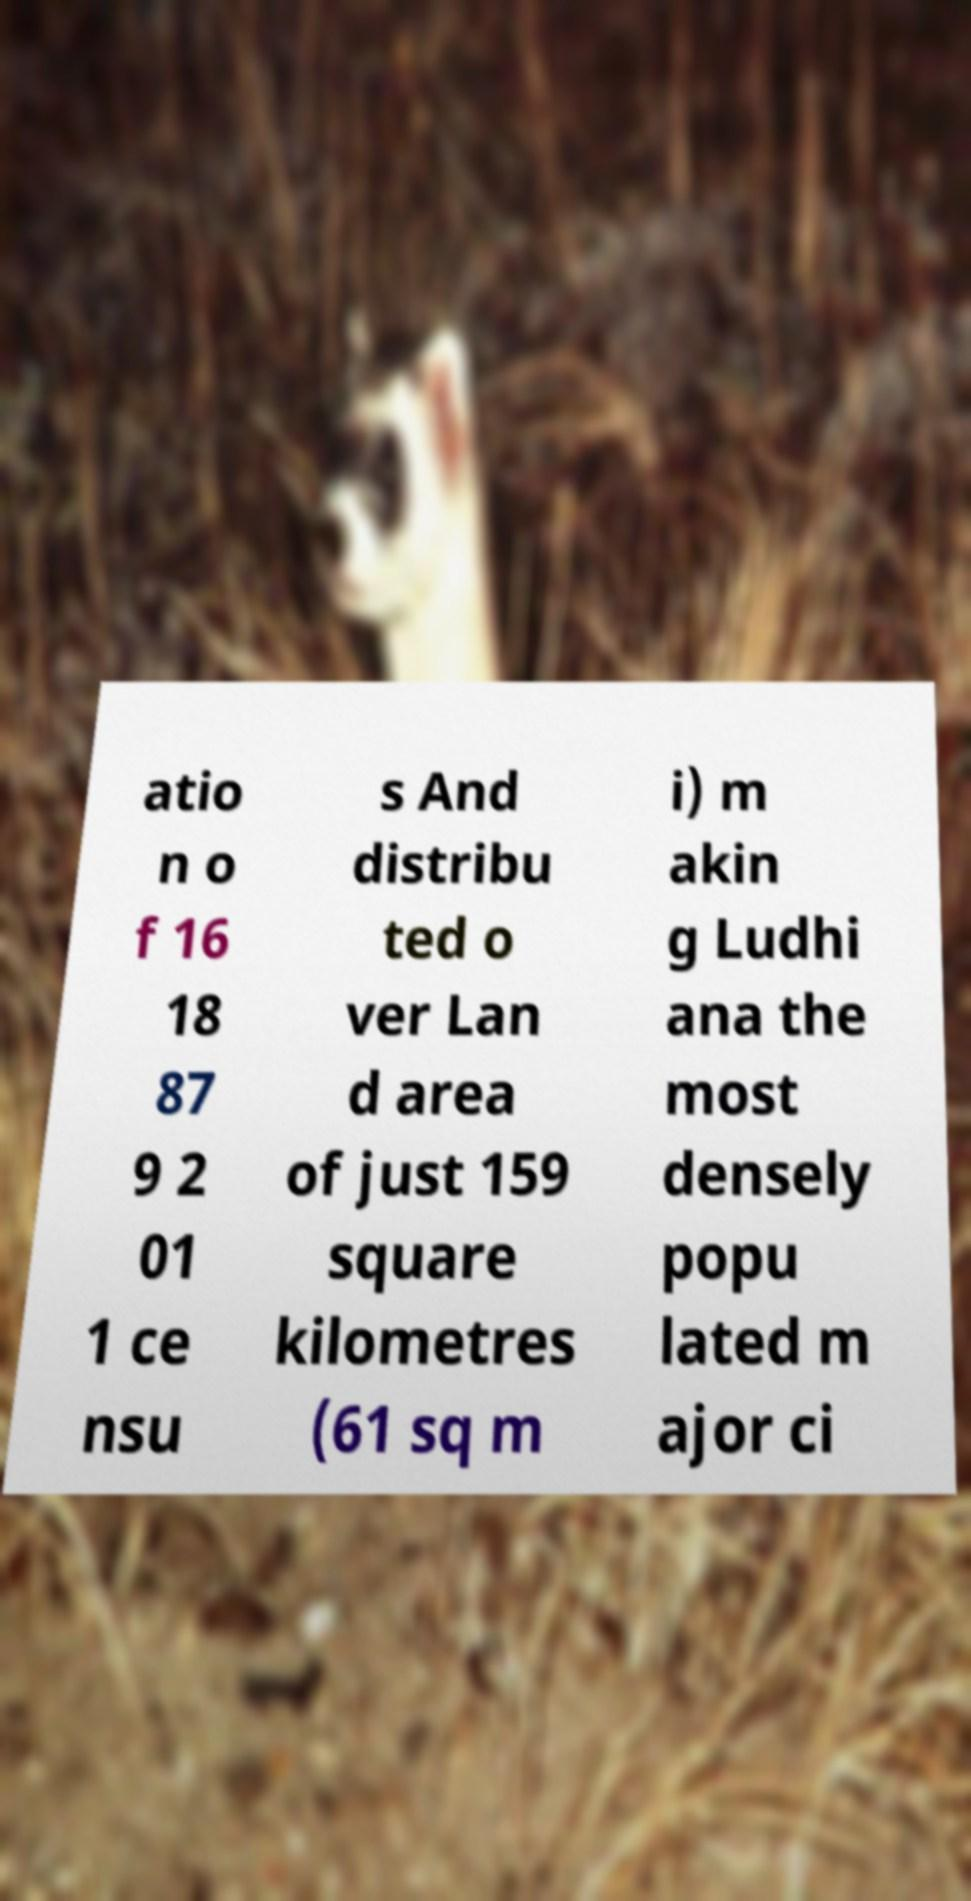For documentation purposes, I need the text within this image transcribed. Could you provide that? atio n o f 16 18 87 9 2 01 1 ce nsu s And distribu ted o ver Lan d area of just 159 square kilometres (61 sq m i) m akin g Ludhi ana the most densely popu lated m ajor ci 